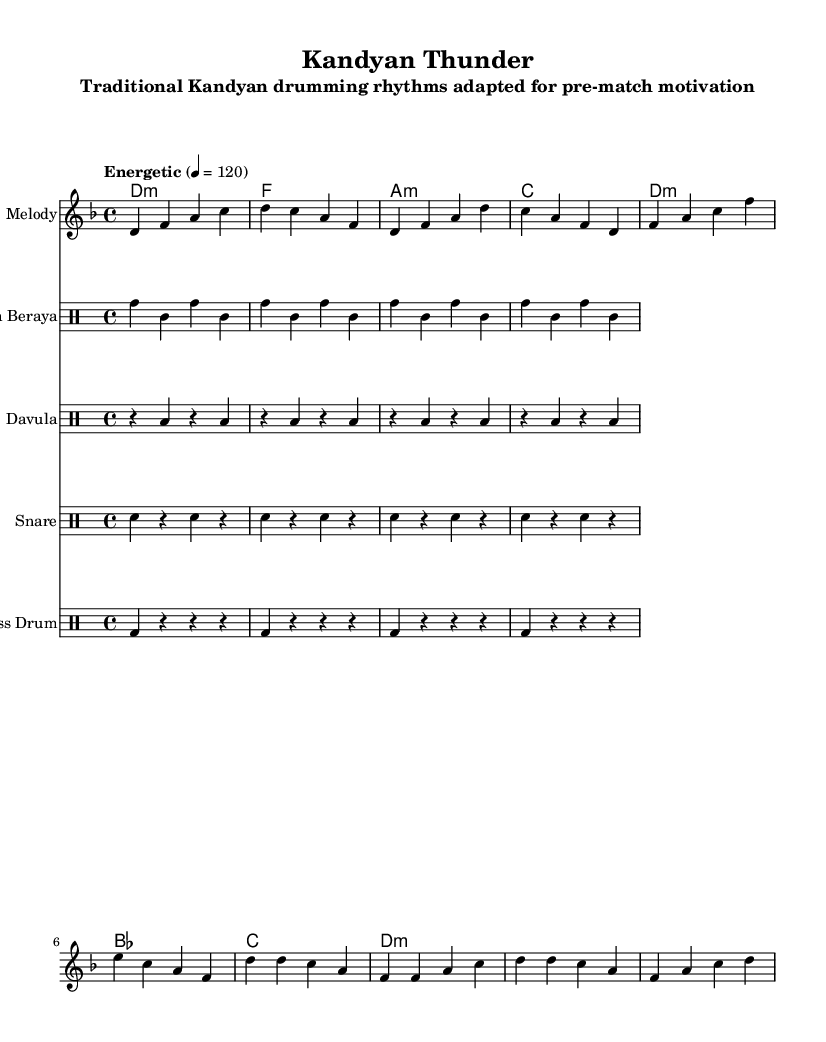What is the key signature of this music? The key signature is D minor, which has one flat (B flat). This is indicated at the beginning of the sheet music, where the key signature is represented.
Answer: D minor What is the time signature of the piece? The time signature is 4/4, which means there are four beats in each measure and the quarter note gets one beat. This is clearly marked at the beginning of the score after the key signature.
Answer: 4/4 What tempo is indicated for this composition? The tempo marking at the start of the music indicates "Energetic" at a speed of 120 beats per minute. This means the music should be played with a lively and quick feel.
Answer: Energetic, 120 How many measures are there in the section labeled as "Verse"? The "Verse" consists of four measures, which can be counted by looking at the music notation and counting the grouped sets of bars within that section.
Answer: 4 What is the primary instrument used for the melody in this sheet? The primary instrument indicated for the melody is labeled as "Melody" on the staff. This will typically be played by a lead instrument or voice, providing the main tune.
Answer: Melody Which drumming rhythm is associated with "Geta Beraya"? The "Geta Beraya" section consists of a repetitive pattern labeled as tomh4 tomml tomh tomml, which is characteristic of this traditional drumming style. This rhythm is important for creating the energetic feel of the piece.
Answer: Geta Beraya What are the chord names associated with the piece? The chords listed throughout the score include D minor, F major, A minor, and C major among others. They support the harmonic structure of the piece and are shown above the melody in chord symbols.
Answer: D minor, F, A minor, C 